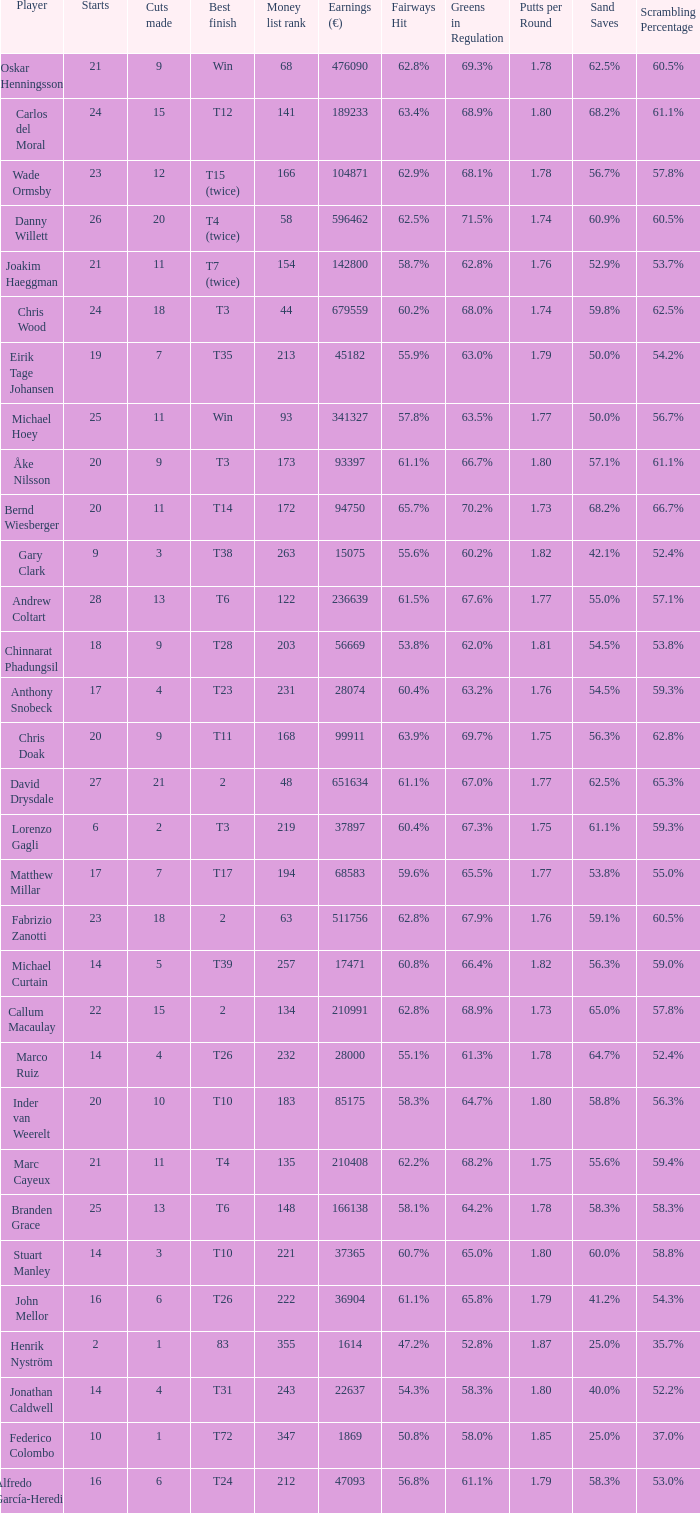How many income values are linked to players with a top finish of t38? 1.0. 